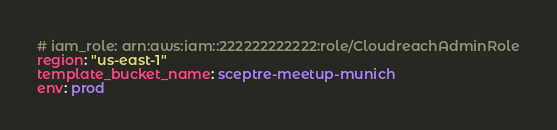Convert code to text. <code><loc_0><loc_0><loc_500><loc_500><_YAML_># iam_role: arn:aws:iam::222222222222:role/CloudreachAdminRole
region: "us-east-1"
template_bucket_name: sceptre-meetup-munich
env: prod
</code> 